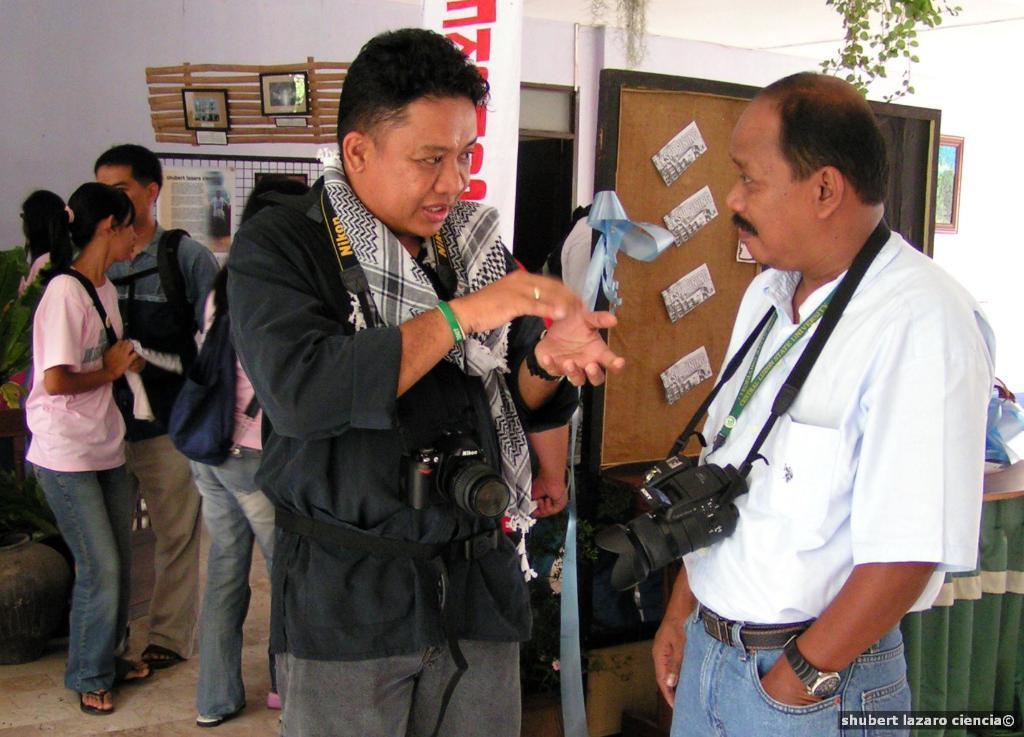In one or two sentences, can you explain what this image depicts? In this image we can see a few people standing, among them some are wearing the cameras, also we can see a board with some posters on it, there is a table, there are some photo frames and posters on the wall. 